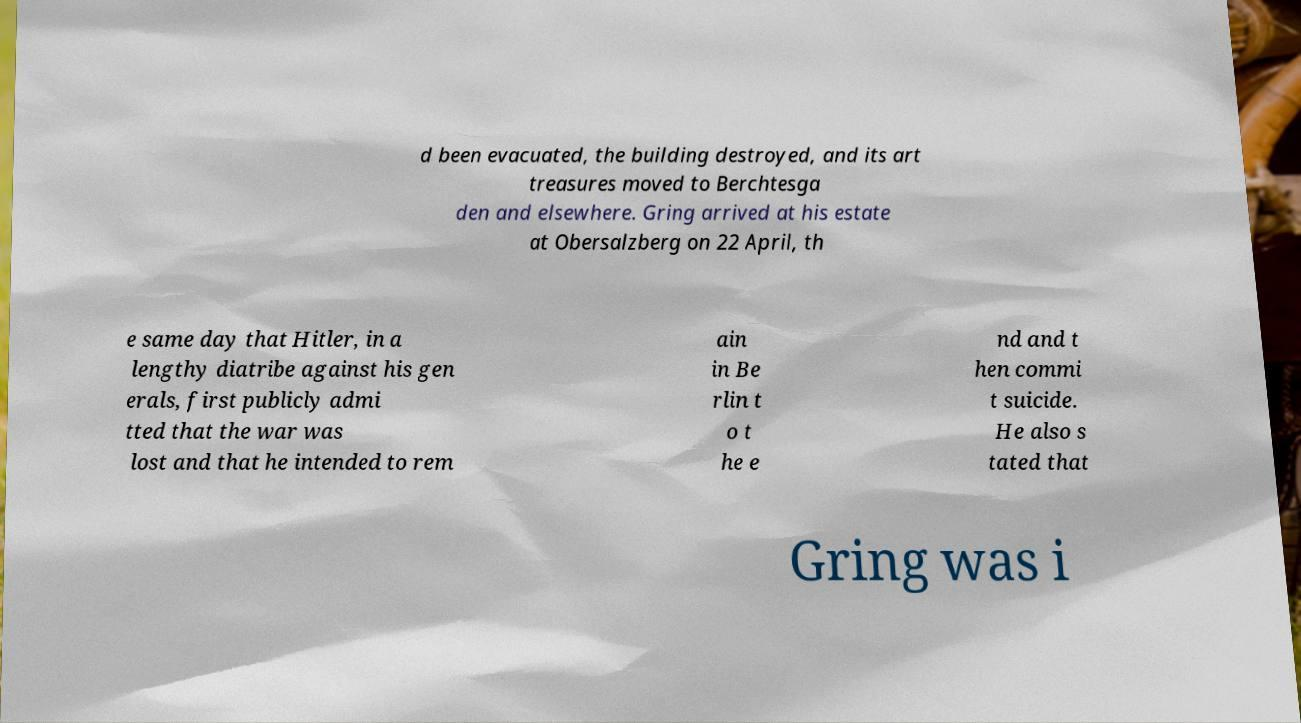Please read and relay the text visible in this image. What does it say? d been evacuated, the building destroyed, and its art treasures moved to Berchtesga den and elsewhere. Gring arrived at his estate at Obersalzberg on 22 April, th e same day that Hitler, in a lengthy diatribe against his gen erals, first publicly admi tted that the war was lost and that he intended to rem ain in Be rlin t o t he e nd and t hen commi t suicide. He also s tated that Gring was i 